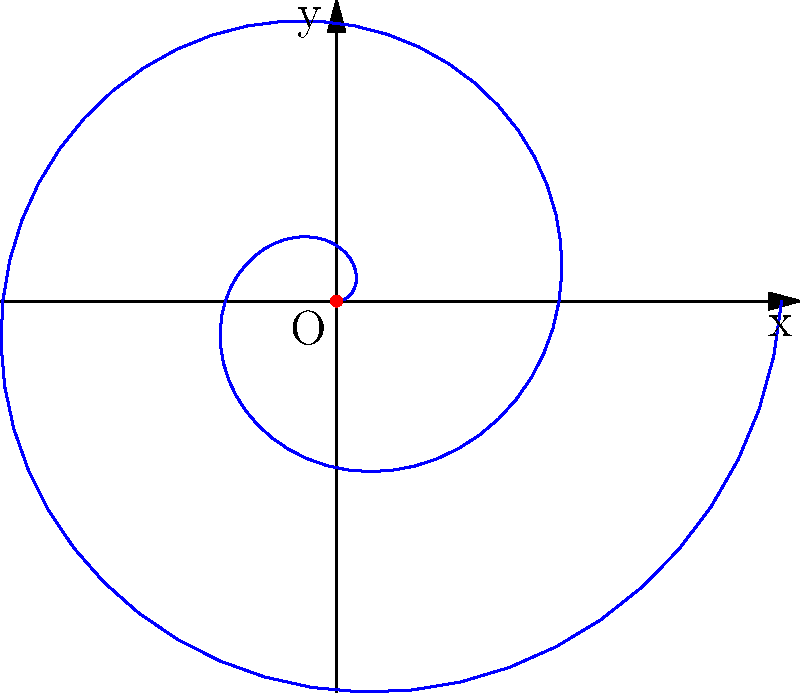In the spiral of Archimedes shown above, the polar equation is given by $r = a\theta$, where $a$ is a positive constant. If the spiral makes two complete revolutions, what is the total angle $\theta$ traversed in radians? To solve this problem, let's follow these steps:

1) Recall that the spiral of Archimedes is defined by the polar equation $r = a\theta$, where $r$ is the radius, $\theta$ is the angle, and $a$ is a positive constant.

2) In polar coordinates, one complete revolution corresponds to an angle of $2\pi$ radians.

3) The question states that the spiral makes two complete revolutions.

4) Therefore, to find the total angle traversed, we need to multiply the angle for one revolution by 2:

   $\theta_{total} = 2 \times 2\pi = 4\pi$ radians

5) This result aligns with our theological background, reminding us of the completeness and perfection often associated with circular forms in sacred geometry.
Answer: $4\pi$ radians 